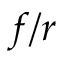Convert formula to latex. <formula><loc_0><loc_0><loc_500><loc_500>f / r</formula> 